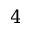<formula> <loc_0><loc_0><loc_500><loc_500>4</formula> 